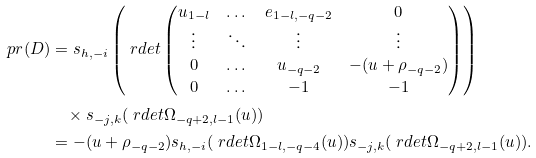Convert formula to latex. <formula><loc_0><loc_0><loc_500><loc_500>\ p r ( D ) & = s _ { h , - i } \left ( \ r d e t \begin{pmatrix} u _ { 1 - l } & \dots & e _ { 1 - l , - q - 2 } & 0 \\ \vdots & \ddots & \vdots & \vdots \\ 0 & \dots & u _ { - q - 2 } & - ( u + \rho _ { - q - 2 } ) \\ 0 & \dots & - 1 & - 1 \end{pmatrix} \right ) \\ & \quad \times s _ { - j , k } ( \ r d e t \Omega _ { - q + 2 , l - 1 } ( u ) ) \\ & = - ( u + \rho _ { - q - 2 } ) s _ { h , - i } ( \ r d e t \Omega _ { 1 - l , - q - 4 } ( u ) ) s _ { - j , k } ( \ r d e t \Omega _ { - q + 2 , l - 1 } ( u ) ) .</formula> 